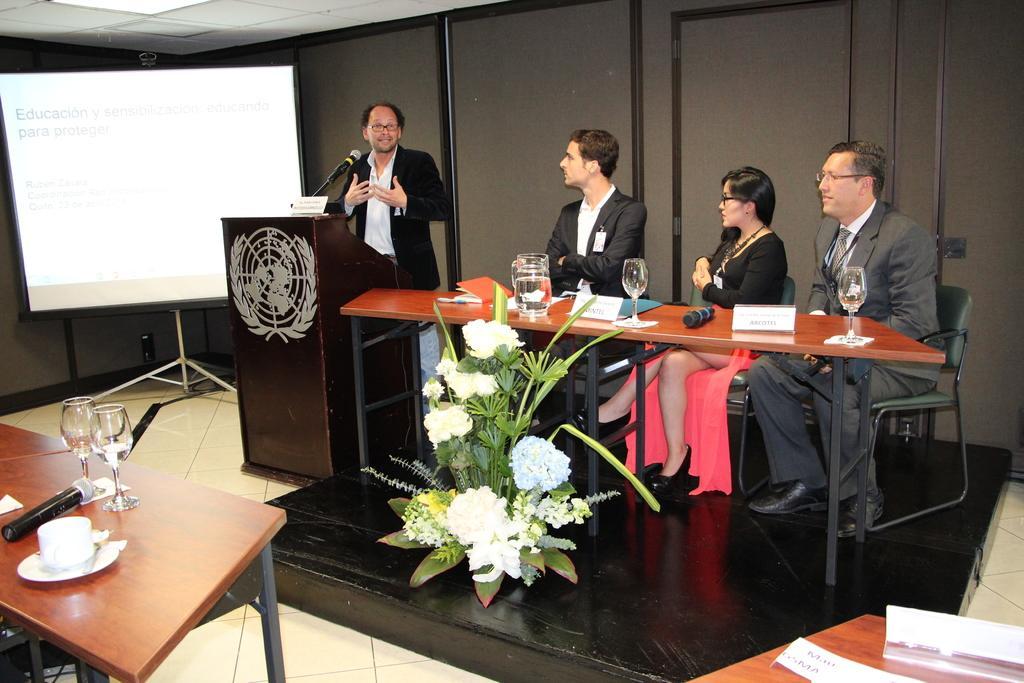Can you describe this image briefly? In this we can see three man and a woman sitting in the room near a table and a man delivering a speech wearing black coat and white shirt near the speech desk. On the table we can see a water jar and glass and a big flower pot on the stage. On the other table we can see another table on which microphone and glass is placed. Just behind that we have projector screen with stand at the corner of the table. 